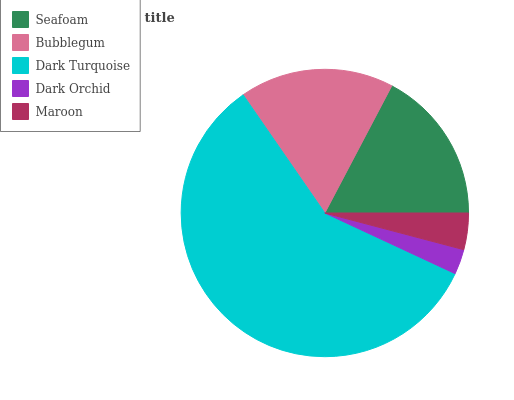Is Dark Orchid the minimum?
Answer yes or no. Yes. Is Dark Turquoise the maximum?
Answer yes or no. Yes. Is Bubblegum the minimum?
Answer yes or no. No. Is Bubblegum the maximum?
Answer yes or no. No. Is Bubblegum greater than Seafoam?
Answer yes or no. Yes. Is Seafoam less than Bubblegum?
Answer yes or no. Yes. Is Seafoam greater than Bubblegum?
Answer yes or no. No. Is Bubblegum less than Seafoam?
Answer yes or no. No. Is Seafoam the high median?
Answer yes or no. Yes. Is Seafoam the low median?
Answer yes or no. Yes. Is Maroon the high median?
Answer yes or no. No. Is Bubblegum the low median?
Answer yes or no. No. 